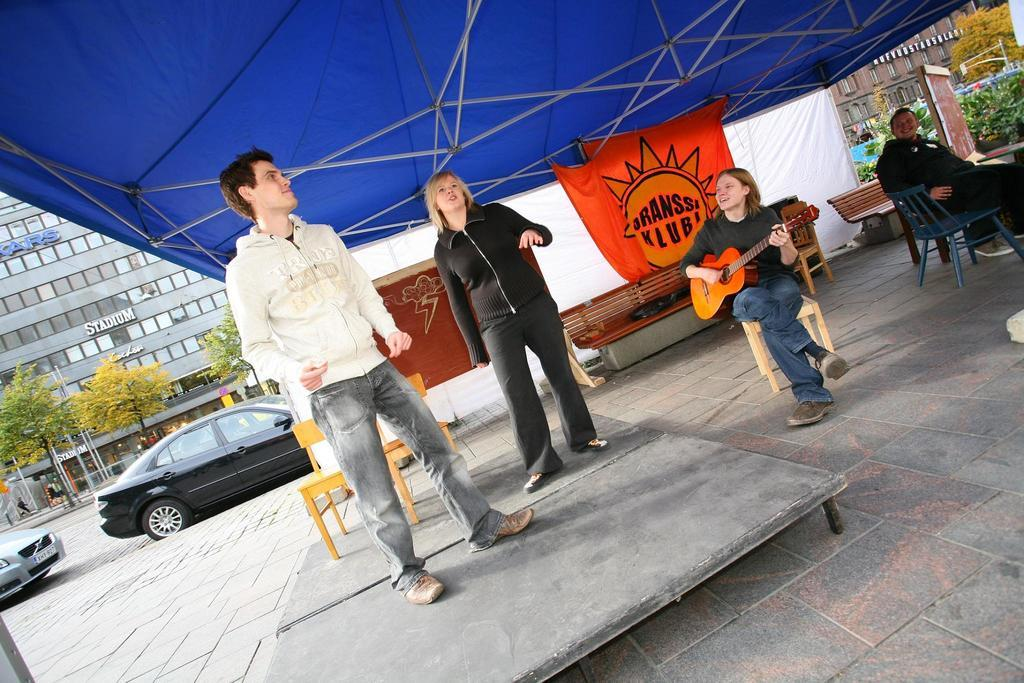What type of structure is visible in the image? There is: There is a building in the image. What else can be seen in the image besides the building? There are trees, two cars on the road, and people in the image. Can you describe the vehicles in the image? There are two cars on the road in the image. What is the woman in the image doing? A woman is sitting in the image and holding a guitar. How many bees are sitting on the twig in the image? There is no twig or bees present in the image. What type of wheel is attached to the guitar in the image? There is no wheel attached to the guitar in the image; it is a musical instrument held by a woman. 